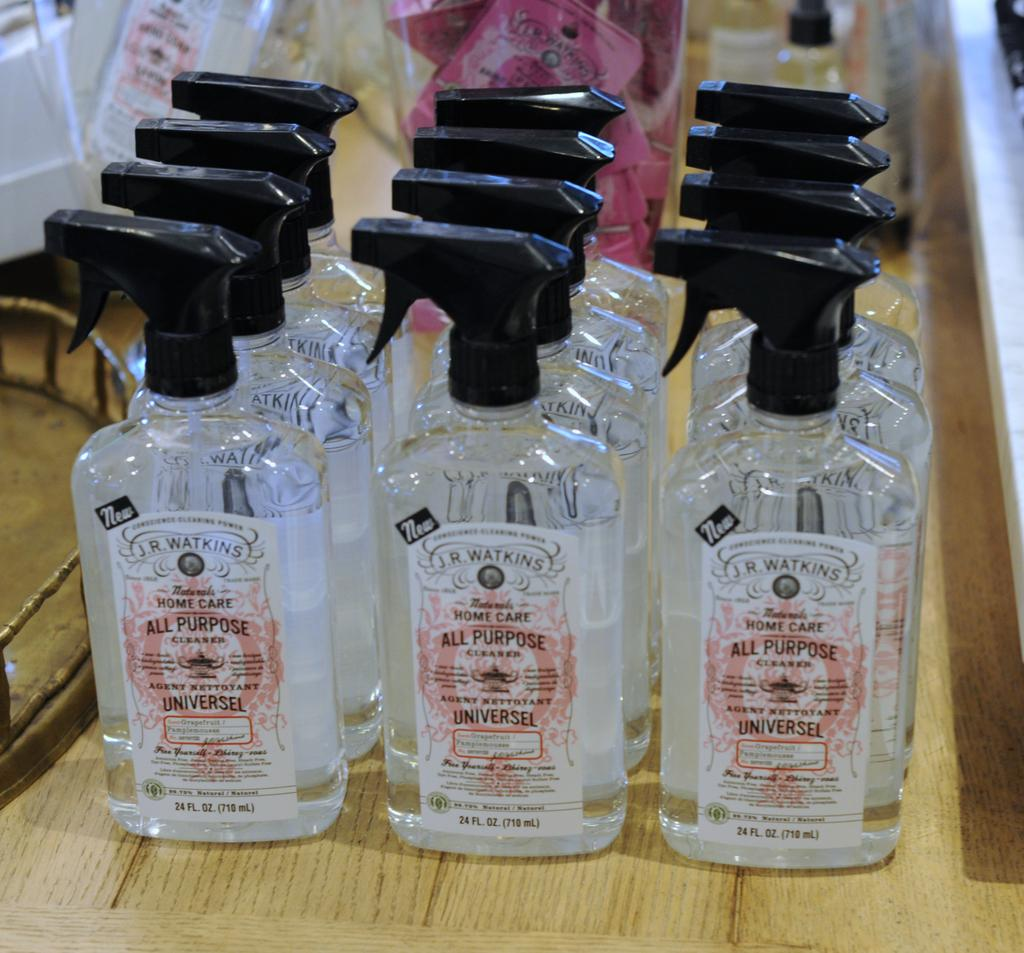<image>
Share a concise interpretation of the image provided. Three rows with 4 containers of JR Watkins cleaners. 